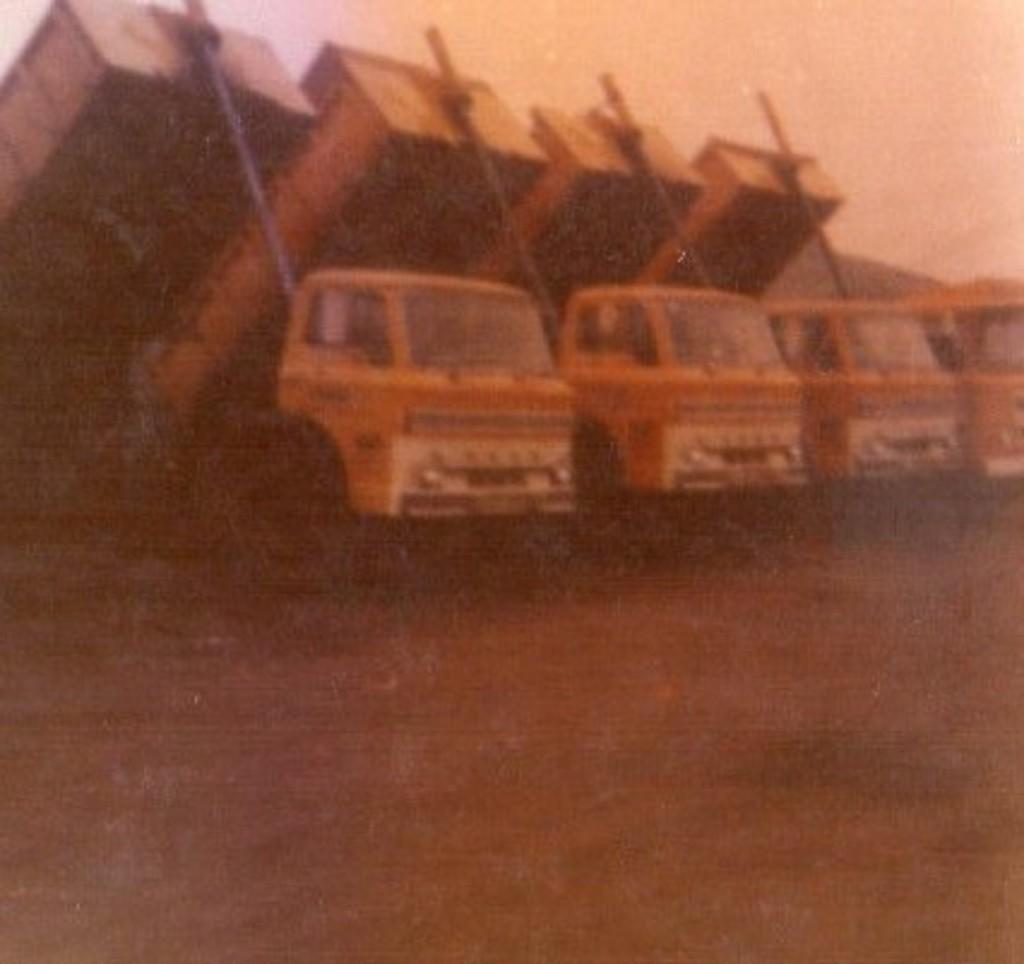What type of objects are present in the image? There are vehicles in the image. What color are the vehicles? The vehicles are yellow. What can be seen in the background of the image? There is sky visible in the background of the image. What news is being reported by the vehicles in the image? There is no news being reported in the image, as vehicles do not have the ability to report news. 